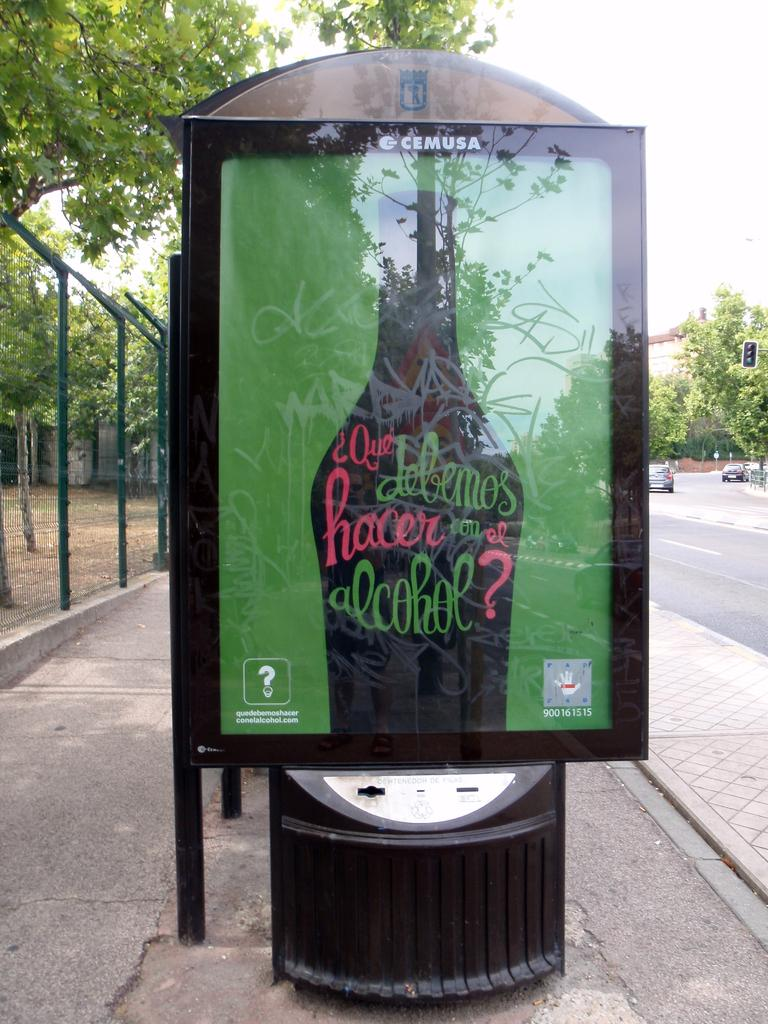<image>
Relay a brief, clear account of the picture shown. silhouette of bottle with Spanish question that starts, Que debemos etc 